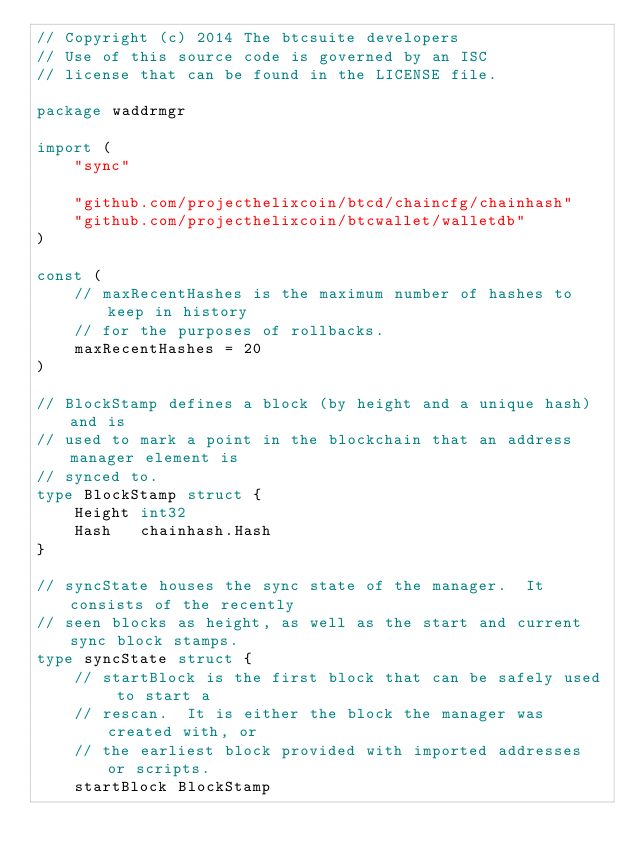<code> <loc_0><loc_0><loc_500><loc_500><_Go_>// Copyright (c) 2014 The btcsuite developers
// Use of this source code is governed by an ISC
// license that can be found in the LICENSE file.

package waddrmgr

import (
	"sync"

	"github.com/projecthelixcoin/btcd/chaincfg/chainhash"
	"github.com/projecthelixcoin/btcwallet/walletdb"
)

const (
	// maxRecentHashes is the maximum number of hashes to keep in history
	// for the purposes of rollbacks.
	maxRecentHashes = 20
)

// BlockStamp defines a block (by height and a unique hash) and is
// used to mark a point in the blockchain that an address manager element is
// synced to.
type BlockStamp struct {
	Height int32
	Hash   chainhash.Hash
}

// syncState houses the sync state of the manager.  It consists of the recently
// seen blocks as height, as well as the start and current sync block stamps.
type syncState struct {
	// startBlock is the first block that can be safely used to start a
	// rescan.  It is either the block the manager was created with, or
	// the earliest block provided with imported addresses or scripts.
	startBlock BlockStamp
</code> 